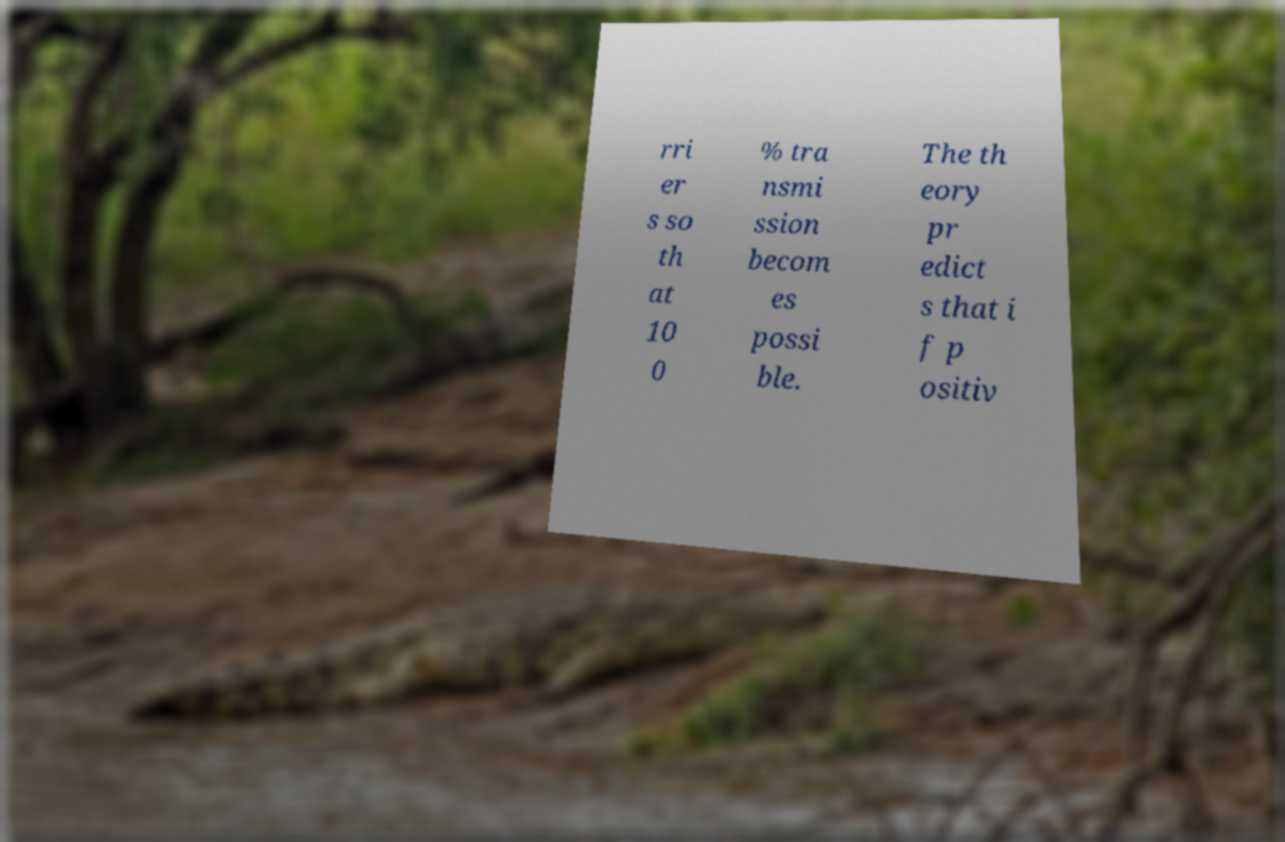I need the written content from this picture converted into text. Can you do that? rri er s so th at 10 0 % tra nsmi ssion becom es possi ble. The th eory pr edict s that i f p ositiv 